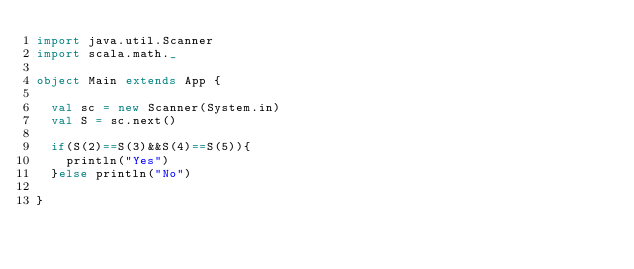<code> <loc_0><loc_0><loc_500><loc_500><_Scala_>import java.util.Scanner
import scala.math._

object Main extends App {

  val sc = new Scanner(System.in)
  val S = sc.next()

  if(S(2)==S(3)&&S(4)==S(5)){
    println("Yes")
  }else println("No")

}

</code> 